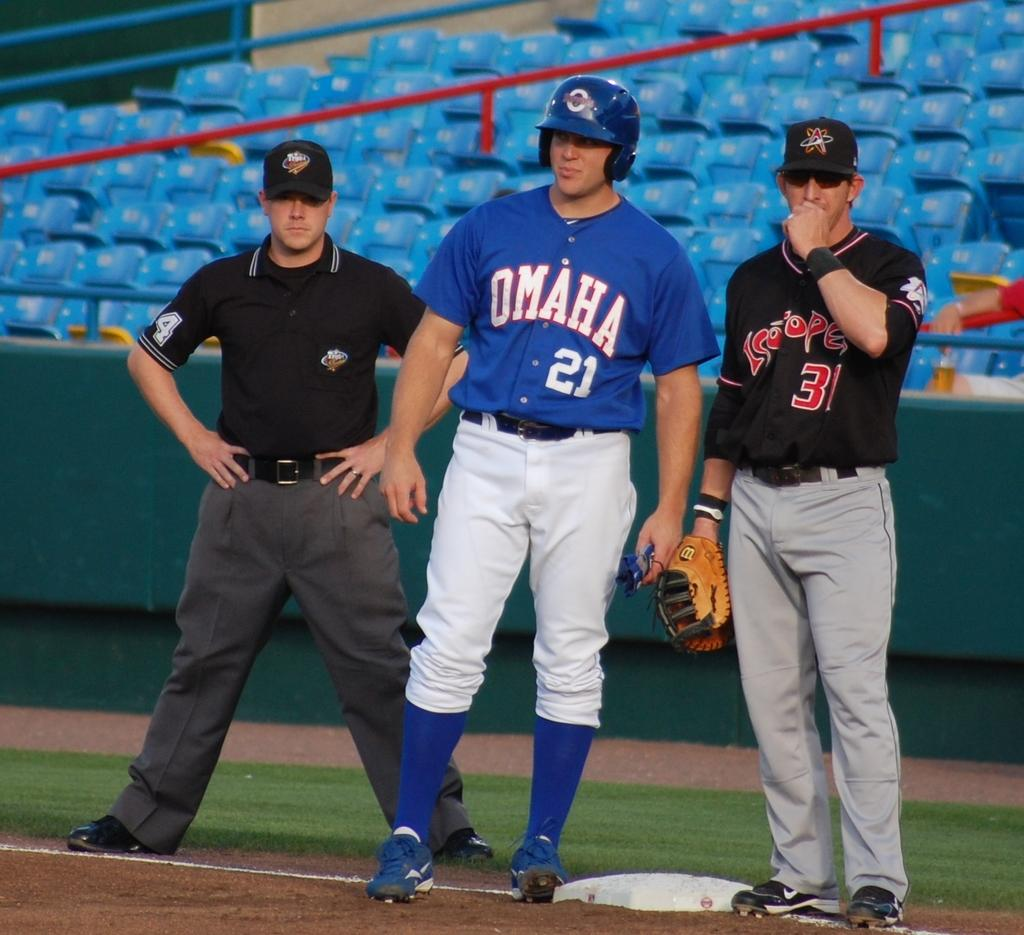<image>
Render a clear and concise summary of the photo. A ball player from Omaha and the Astros stand on the sideline with a referee. 